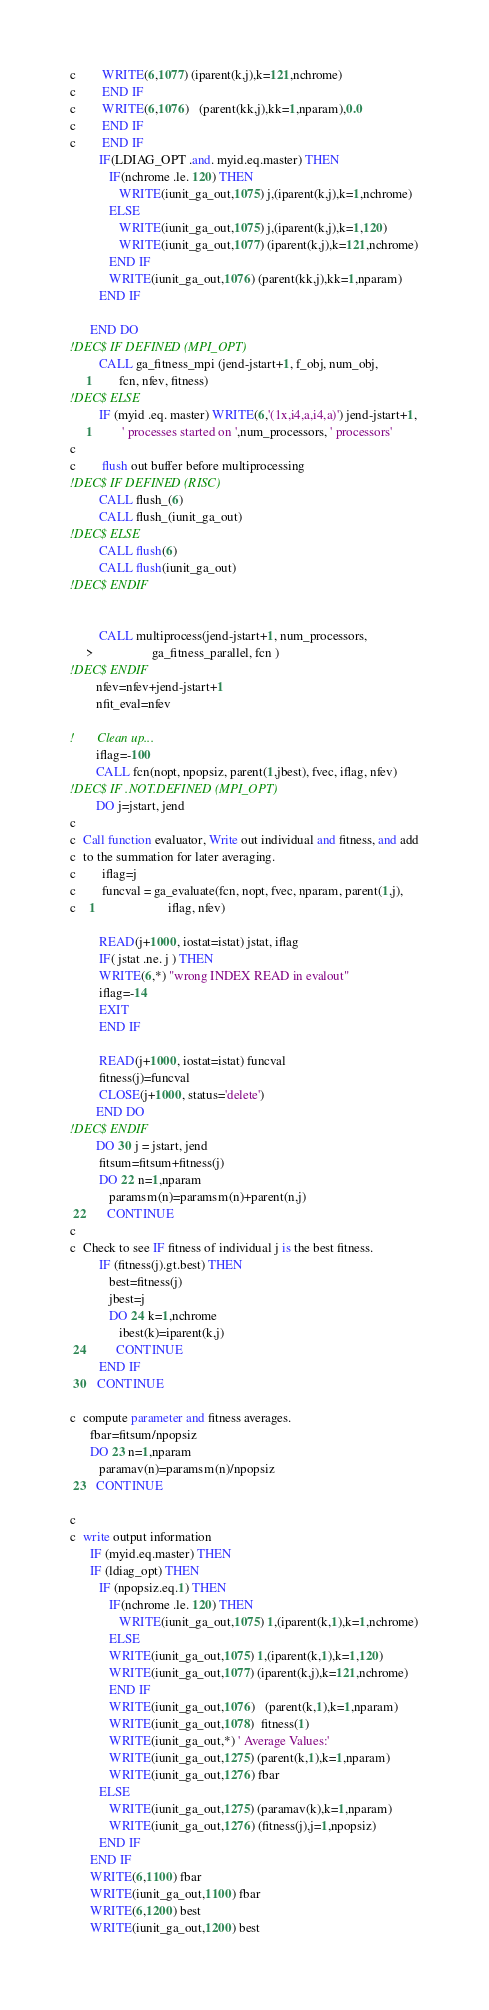Convert code to text. <code><loc_0><loc_0><loc_500><loc_500><_FORTRAN_>c        WRITE(6,1077) (iparent(k,j),k=121,nchrome)
c        END IF
c        WRITE(6,1076)   (parent(kk,j),kk=1,nparam),0.0
c        END IF
c        END IF
         IF(LDIAG_OPT .and. myid.eq.master) THEN
            IF(nchrome .le. 120) THEN
               WRITE(iunit_ga_out,1075) j,(iparent(k,j),k=1,nchrome)
            ELSE
               WRITE(iunit_ga_out,1075) j,(iparent(k,j),k=1,120)
               WRITE(iunit_ga_out,1077) (iparent(k,j),k=121,nchrome)
            END IF
            WRITE(iunit_ga_out,1076) (parent(kk,j),kk=1,nparam)
         END IF

      END DO
!DEC$ IF DEFINED (MPI_OPT)
         CALL ga_fitness_mpi (jend-jstart+1, f_obj, num_obj,
     1        fcn, nfev, fitness)
!DEC$ ELSE
         IF (myid .eq. master) WRITE(6,'(1x,i4,a,i4,a)') jend-jstart+1,
     1         ' processes started on ',num_processors, ' processors'
c
c        flush out buffer before multiprocessing
!DEC$ IF DEFINED (RISC)
         CALL flush_(6)
         CALL flush_(iunit_ga_out)
!DEC$ ELSE
         CALL flush(6)
         CALL flush(iunit_ga_out)
!DEC$ ENDIF


         CALL multiprocess(jend-jstart+1, num_processors,
     >                  ga_fitness_parallel, fcn )
!DEC$ ENDIF
        nfev=nfev+jend-jstart+1
        nfit_eval=nfev

!       Clean up...
        iflag=-100
        CALL fcn(nopt, npopsiz, parent(1,jbest), fvec, iflag, nfev)
!DEC$ IF .NOT.DEFINED (MPI_OPT)
        DO j=jstart, jend
c
c  Call function evaluator, Write out individual and fitness, and add
c  to the summation for later averaging.
c        iflag=j
c        funcval = ga_evaluate(fcn, nopt, fvec, nparam, parent(1,j),
c    1                      iflag, nfev)

         READ(j+1000, iostat=istat) jstat, iflag
         IF( jstat .ne. j ) THEN
         WRITE(6,*) "wrong INDEX READ in evalout"
         iflag=-14
         EXIT
         END IF

         READ(j+1000, iostat=istat) funcval
         fitness(j)=funcval
         CLOSE(j+1000, status='delete')
        END DO
!DEC$ ENDIF
        DO 30 j = jstart, jend
         fitsum=fitsum+fitness(j)
         DO 22 n=1,nparam
            paramsm(n)=paramsm(n)+parent(n,j)
 22      CONTINUE
c
c  Check to see IF fitness of individual j is the best fitness.
         IF (fitness(j).gt.best) THEN
            best=fitness(j)
            jbest=j
            DO 24 k=1,nchrome
               ibest(k)=iparent(k,j)
 24         CONTINUE
         END IF
 30   CONTINUE

c  compute parameter and fitness averages.
      fbar=fitsum/npopsiz
      DO 23 n=1,nparam
         paramav(n)=paramsm(n)/npopsiz
 23   CONTINUE

c
c  write output information
      IF (myid.eq.master) THEN
      IF (ldiag_opt) THEN
         IF (npopsiz.eq.1) THEN
            IF(nchrome .le. 120) THEN
               WRITE(iunit_ga_out,1075) 1,(iparent(k,1),k=1,nchrome)
            ELSE
            WRITE(iunit_ga_out,1075) 1,(iparent(k,1),k=1,120)
            WRITE(iunit_ga_out,1077) (iparent(k,j),k=121,nchrome)
            END IF
            WRITE(iunit_ga_out,1076)   (parent(k,1),k=1,nparam)
            WRITE(iunit_ga_out,1078)  fitness(1)
            WRITE(iunit_ga_out,*) ' Average Values:'
            WRITE(iunit_ga_out,1275) (parent(k,1),k=1,nparam)
            WRITE(iunit_ga_out,1276) fbar
         ELSE
            WRITE(iunit_ga_out,1275) (paramav(k),k=1,nparam)
            WRITE(iunit_ga_out,1276) (fitness(j),j=1,npopsiz)
         END IF
      END IF
      WRITE(6,1100) fbar
      WRITE(iunit_ga_out,1100) fbar
      WRITE(6,1200) best
      WRITE(iunit_ga_out,1200) best</code> 